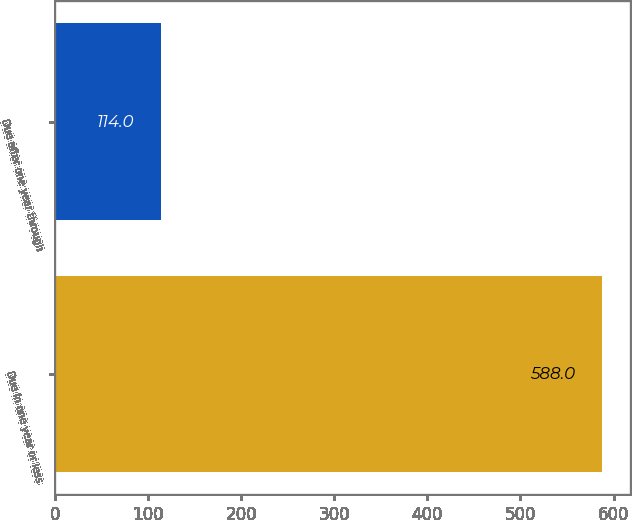Convert chart. <chart><loc_0><loc_0><loc_500><loc_500><bar_chart><fcel>Due in one year or less<fcel>Due after one year through<nl><fcel>588<fcel>114<nl></chart> 